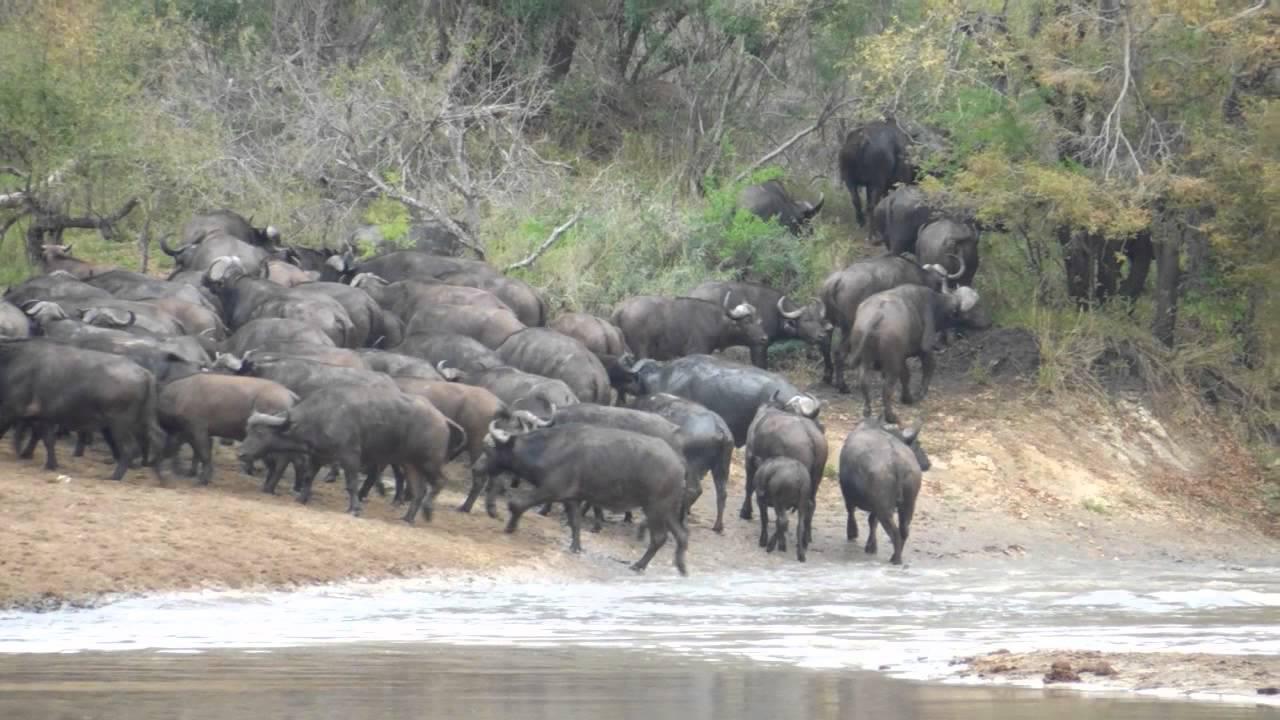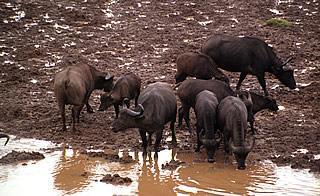The first image is the image on the left, the second image is the image on the right. For the images shown, is this caption "None of the animals are completely in the water." true? Answer yes or no. Yes. The first image is the image on the left, the second image is the image on the right. Examine the images to the left and right. Is the description "Each image shows multiple horned animals standing at least chest-deep in water, and one image includes some animals standing behind water on higher ground near a fence." accurate? Answer yes or no. No. 